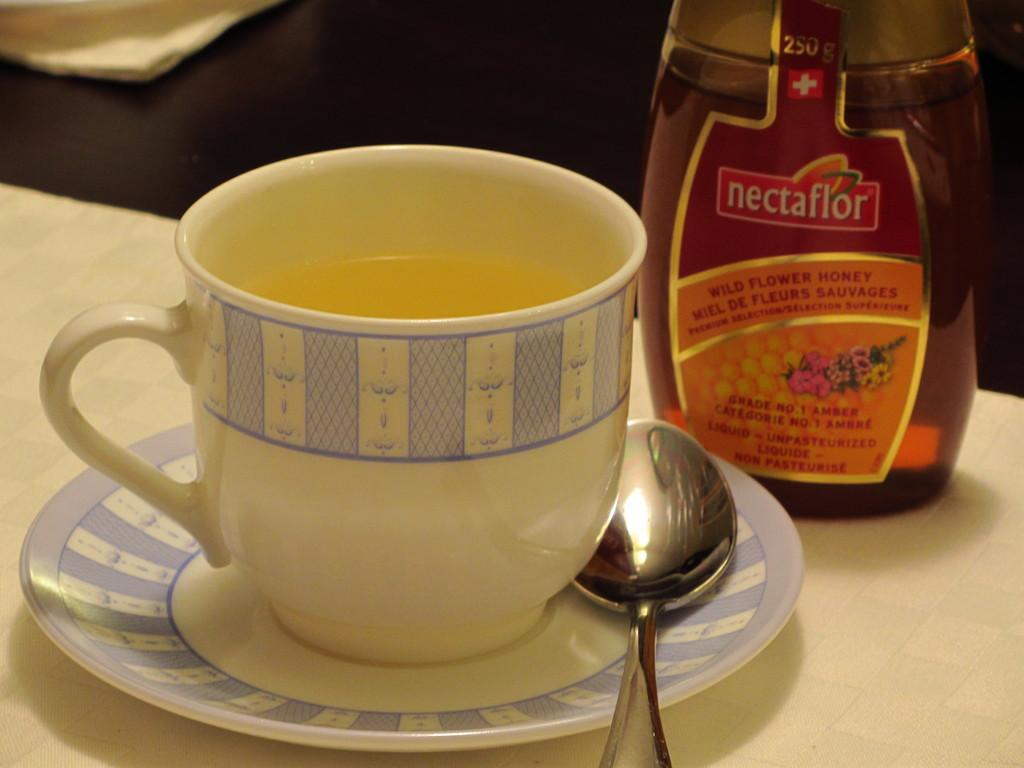What is the main object in the image? There is a honey water cup in the image. What other objects are related to the honey water cup? There is a saucer with a spoon and a honey bottle in the image. Where are these objects placed? All these objects are placed on a table. How many trees can be seen in the image? There are no trees visible in the image. Is the honey water hot in the image? The provided facts do not mention the temperature of the honey water, so we cannot determine if it is hot or not. 